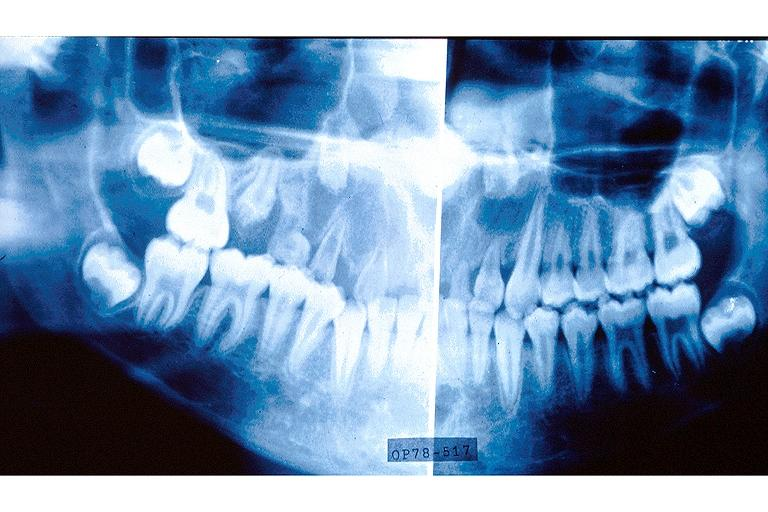what does this image show?
Answer the question using a single word or phrase. Regional odontodysplasia 